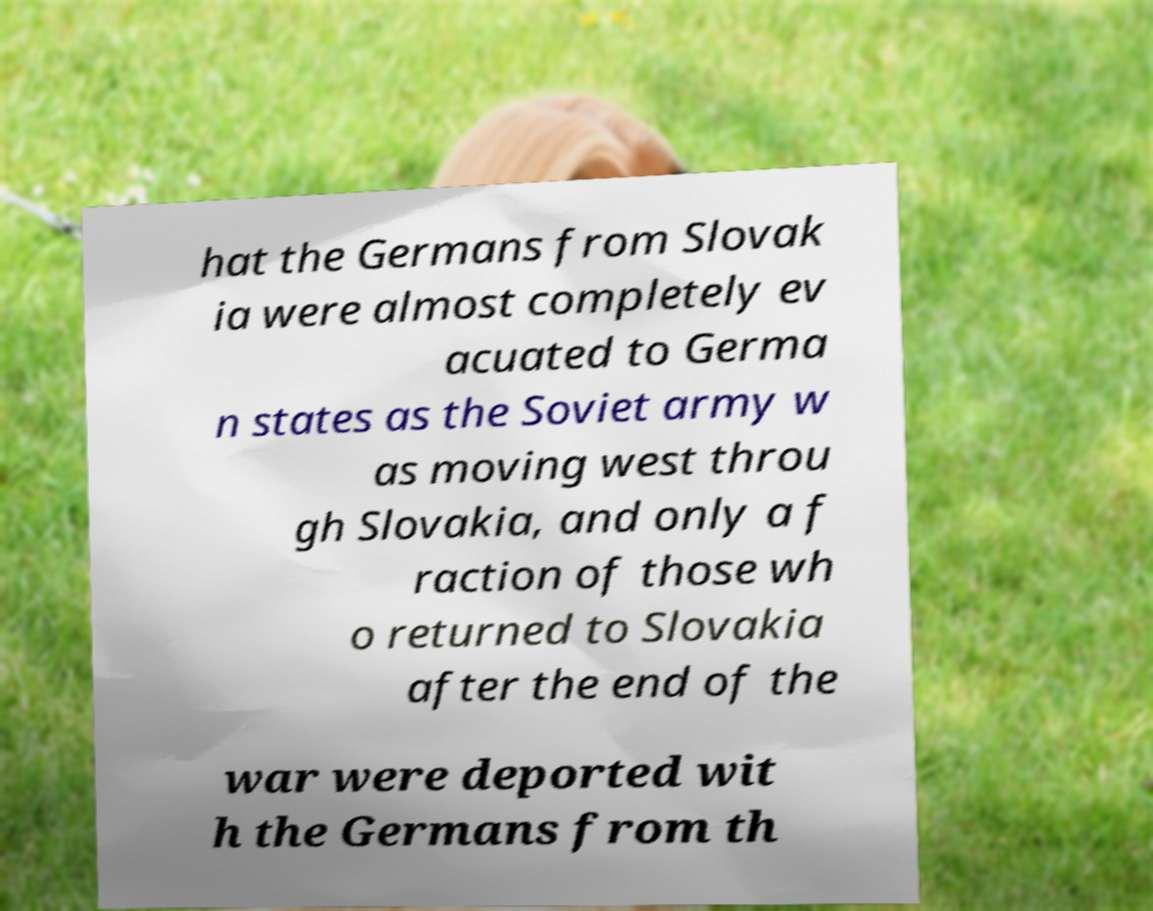Can you accurately transcribe the text from the provided image for me? hat the Germans from Slovak ia were almost completely ev acuated to Germa n states as the Soviet army w as moving west throu gh Slovakia, and only a f raction of those wh o returned to Slovakia after the end of the war were deported wit h the Germans from th 